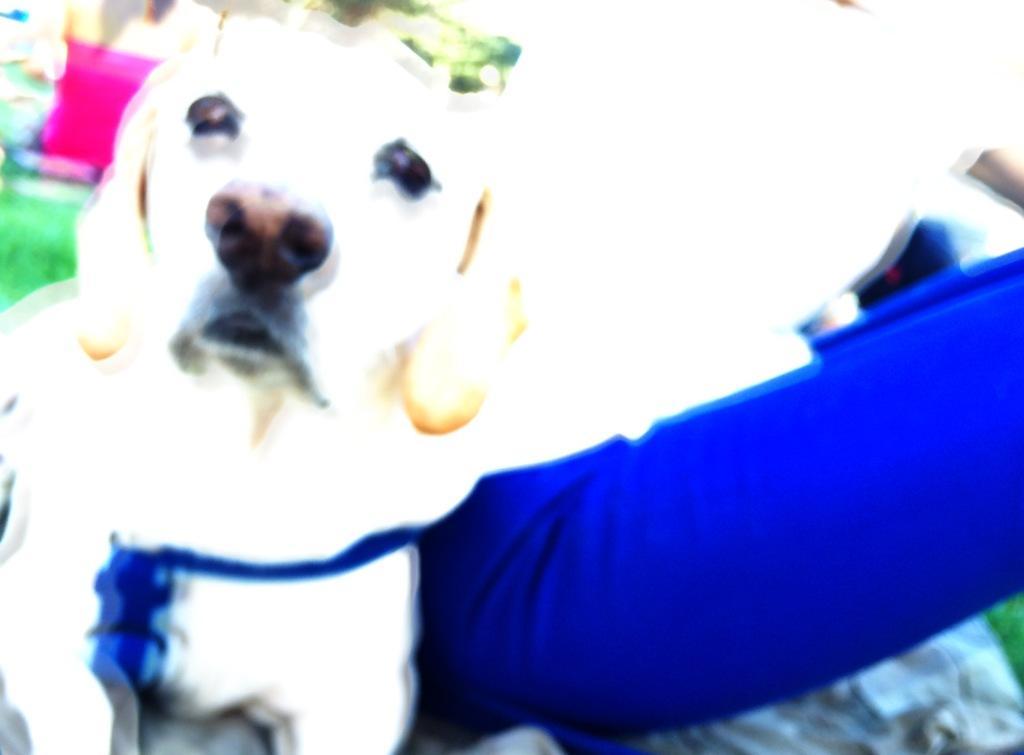Could you give a brief overview of what you see in this image? In this image there is a dog. At the bottom of the image there is grass on the surface. 